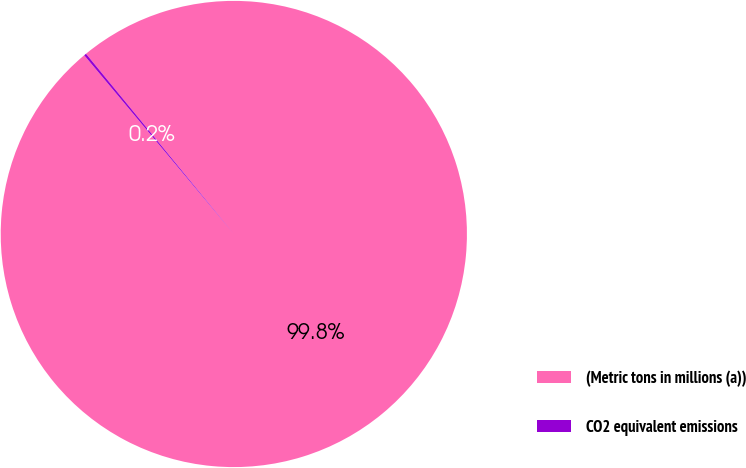Convert chart to OTSL. <chart><loc_0><loc_0><loc_500><loc_500><pie_chart><fcel>(Metric tons in millions (a))<fcel>CO2 equivalent emissions<nl><fcel>99.84%<fcel>0.16%<nl></chart> 